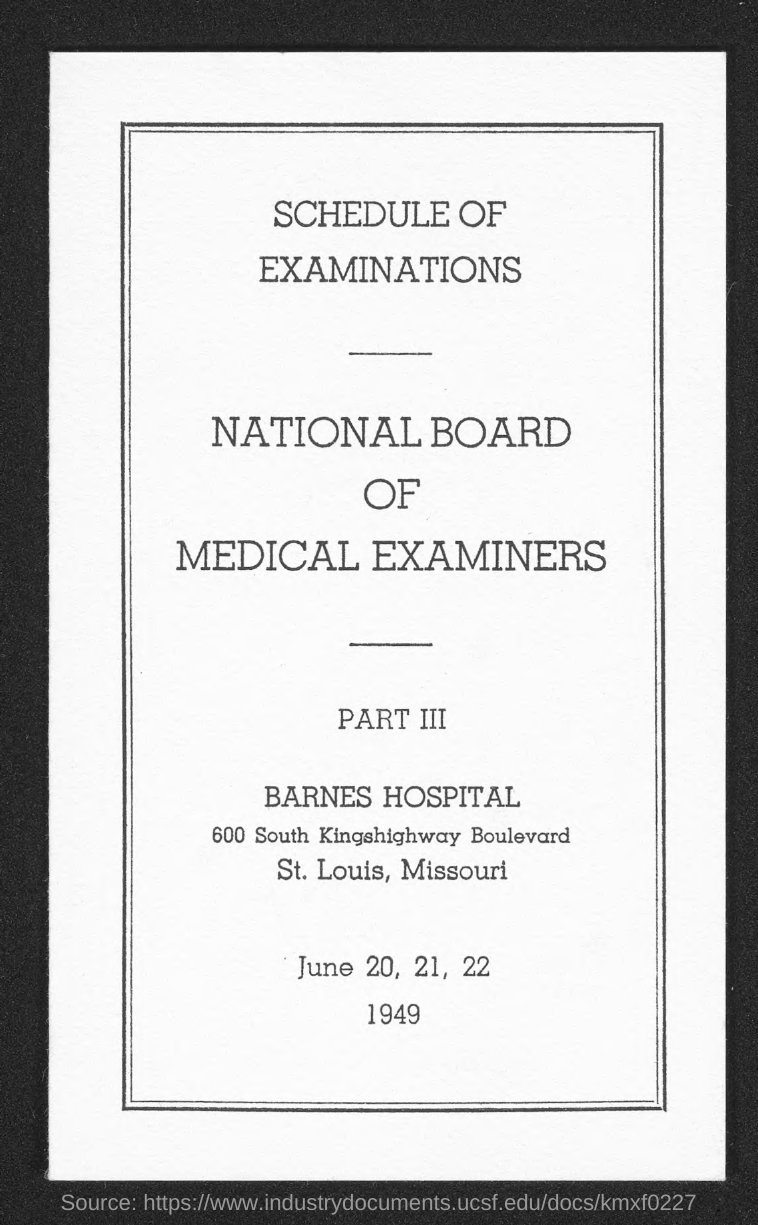What is the Title of the document?
Make the answer very short. Schedule of Examinations. 